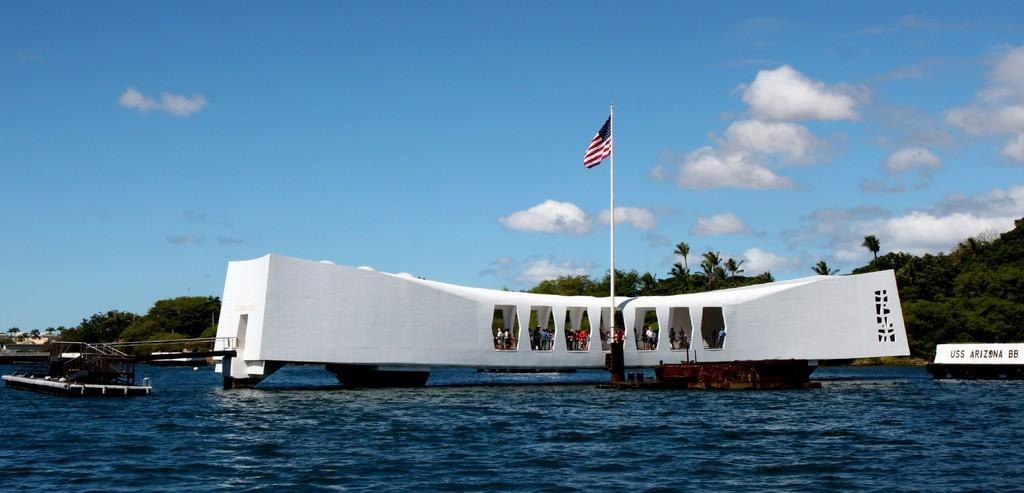<image>
Relay a brief, clear account of the picture shown. An odd-looking boat is next to the USS Arizona on the water. 